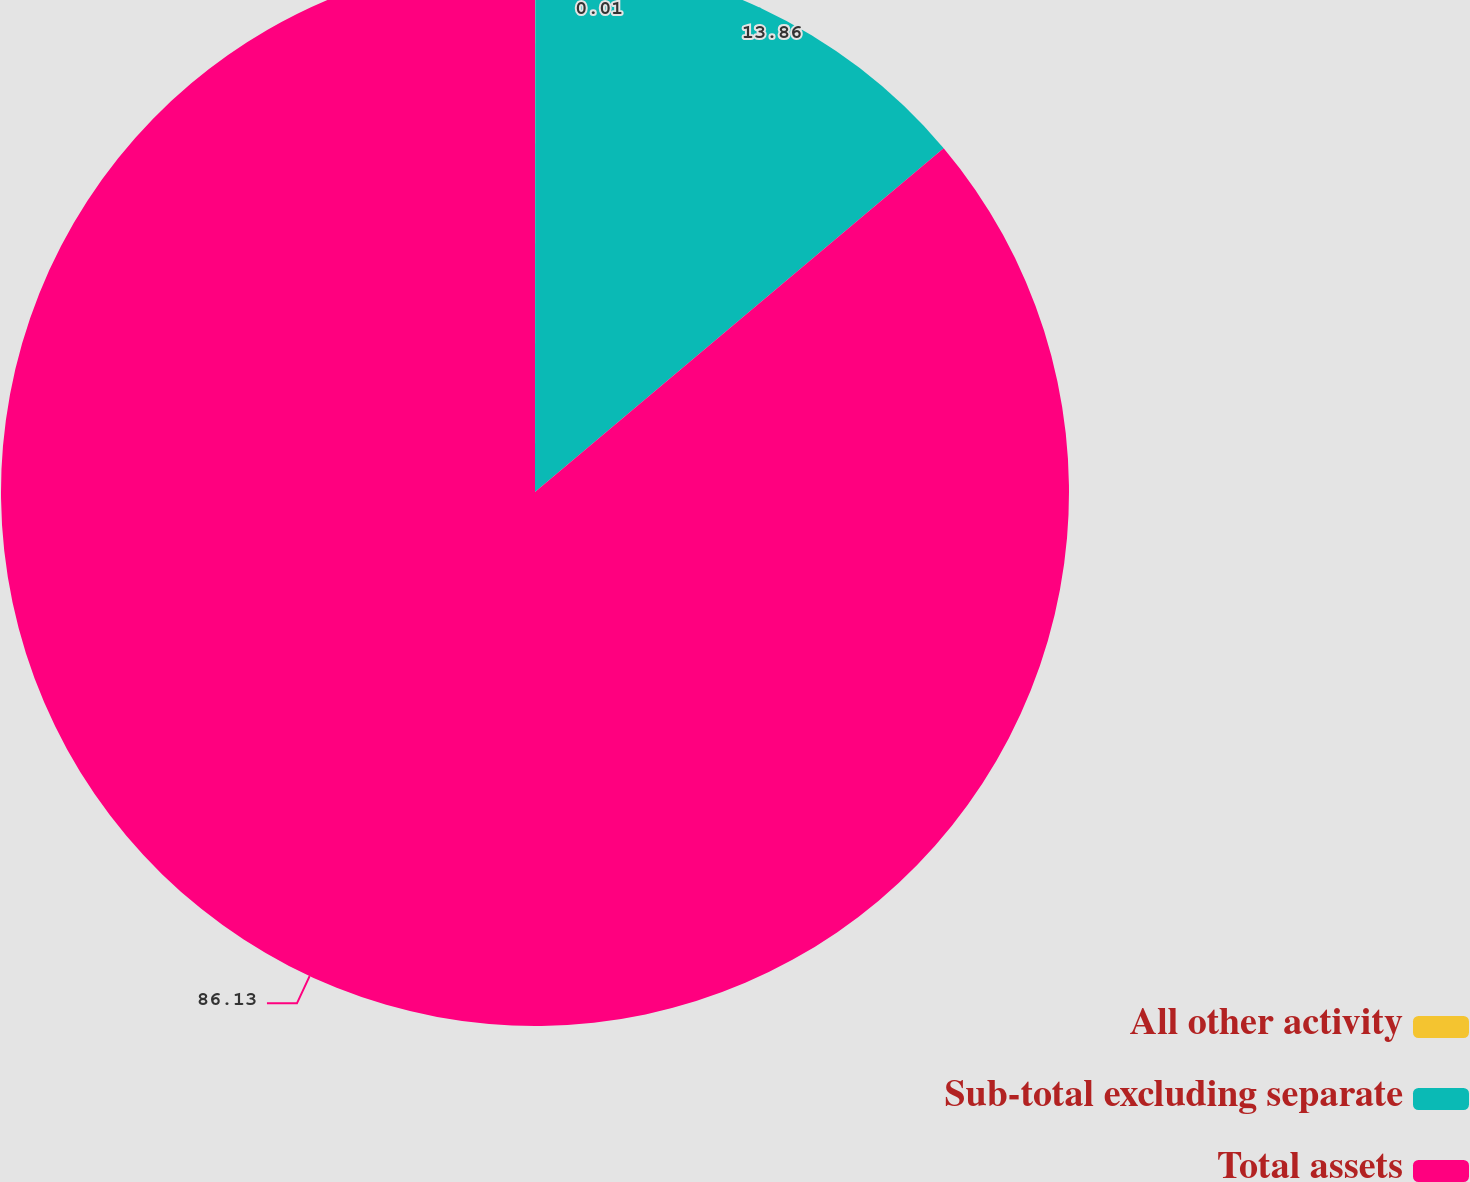<chart> <loc_0><loc_0><loc_500><loc_500><pie_chart><fcel>All other activity<fcel>Sub-total excluding separate<fcel>Total assets<nl><fcel>0.01%<fcel>13.86%<fcel>86.13%<nl></chart> 